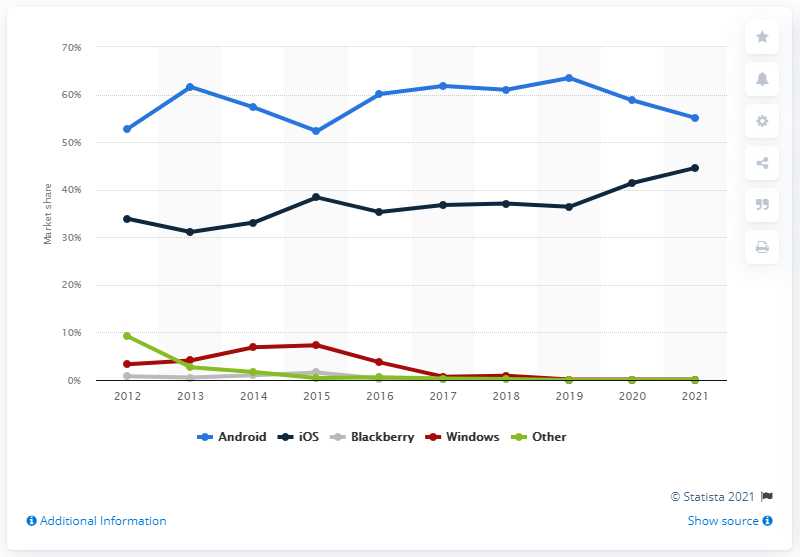What operating system has been increasing its market share over the past decade? Based on the line graph in the image, Android OS has shown an overall increase in market share over the past decade. While iOS also appears to have increased slightly, the most significant growth is seen in Android's trajectory. 